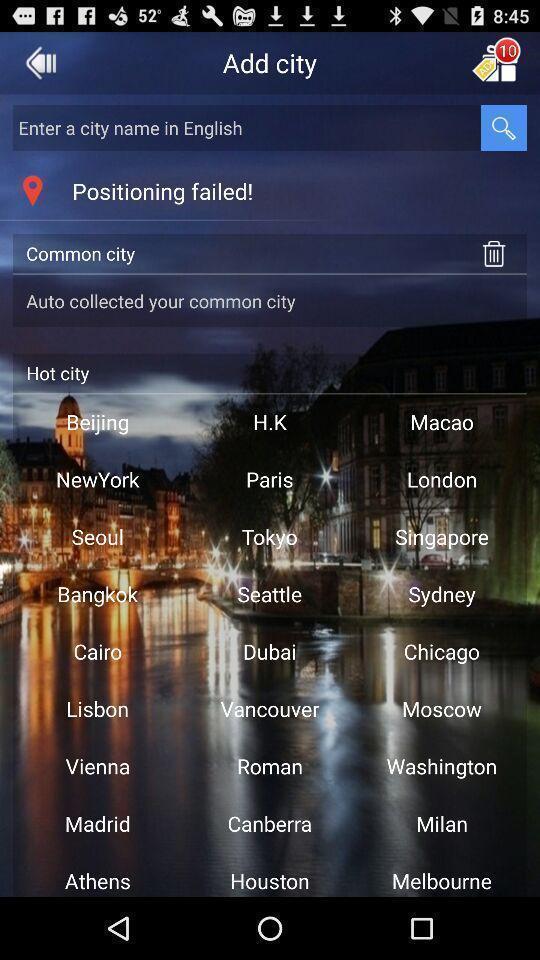What details can you identify in this image? Search page to find city. 